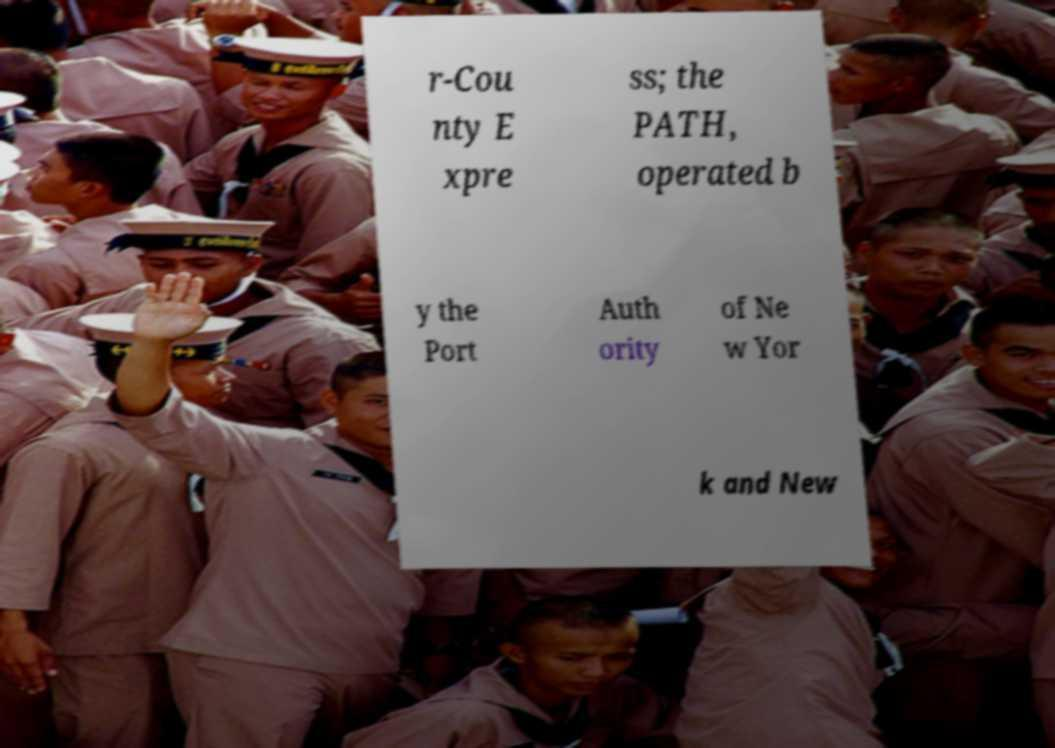I need the written content from this picture converted into text. Can you do that? r-Cou nty E xpre ss; the PATH, operated b y the Port Auth ority of Ne w Yor k and New 